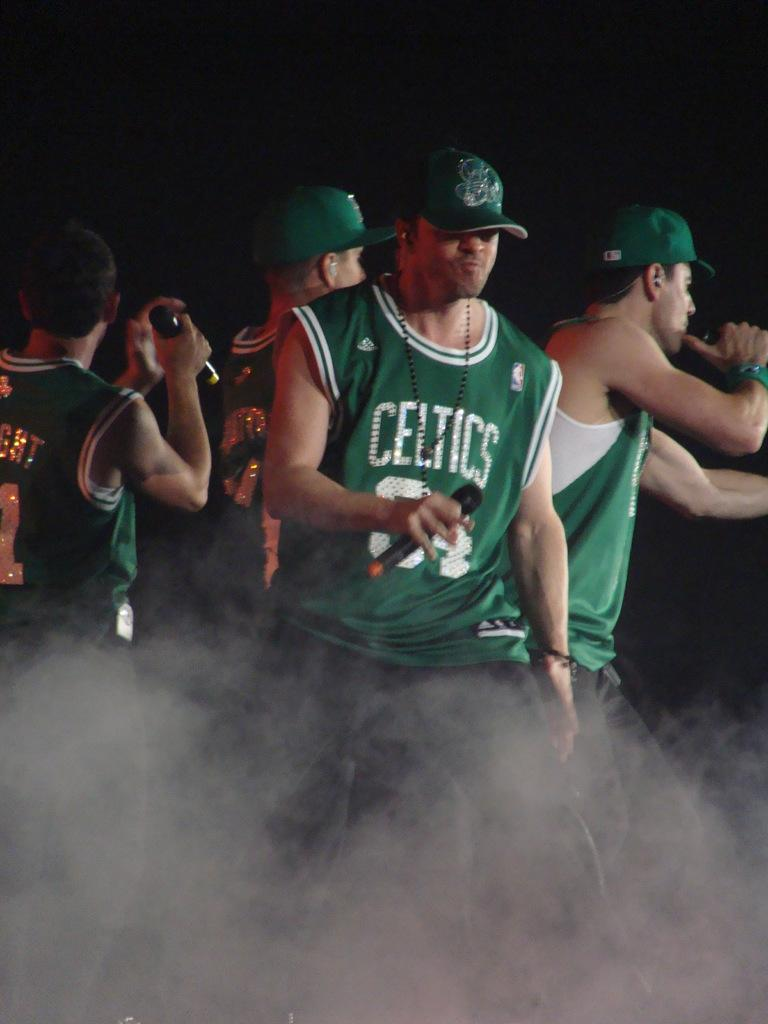<image>
Write a terse but informative summary of the picture. A man holding a microphone wears a green Celtics jersey. 